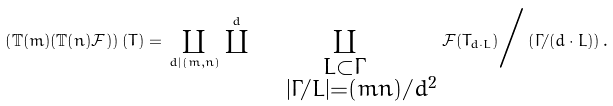<formula> <loc_0><loc_0><loc_500><loc_500>\left ( \mathbb { T } ( m ) ( \mathbb { T } ( n ) \mathcal { F } ) \right ) ( T ) = \, \coprod _ { d | ( m , n ) } \, \coprod ^ { d } \, \coprod _ { \substack { L \subset \Gamma \\ \quad | \Gamma / L | = ( m n ) / d ^ { 2 } } } \, \mathcal { F } ( T _ { d \cdot L } ) \Big / \left ( \Gamma / ( d \cdot L ) \right ) .</formula> 